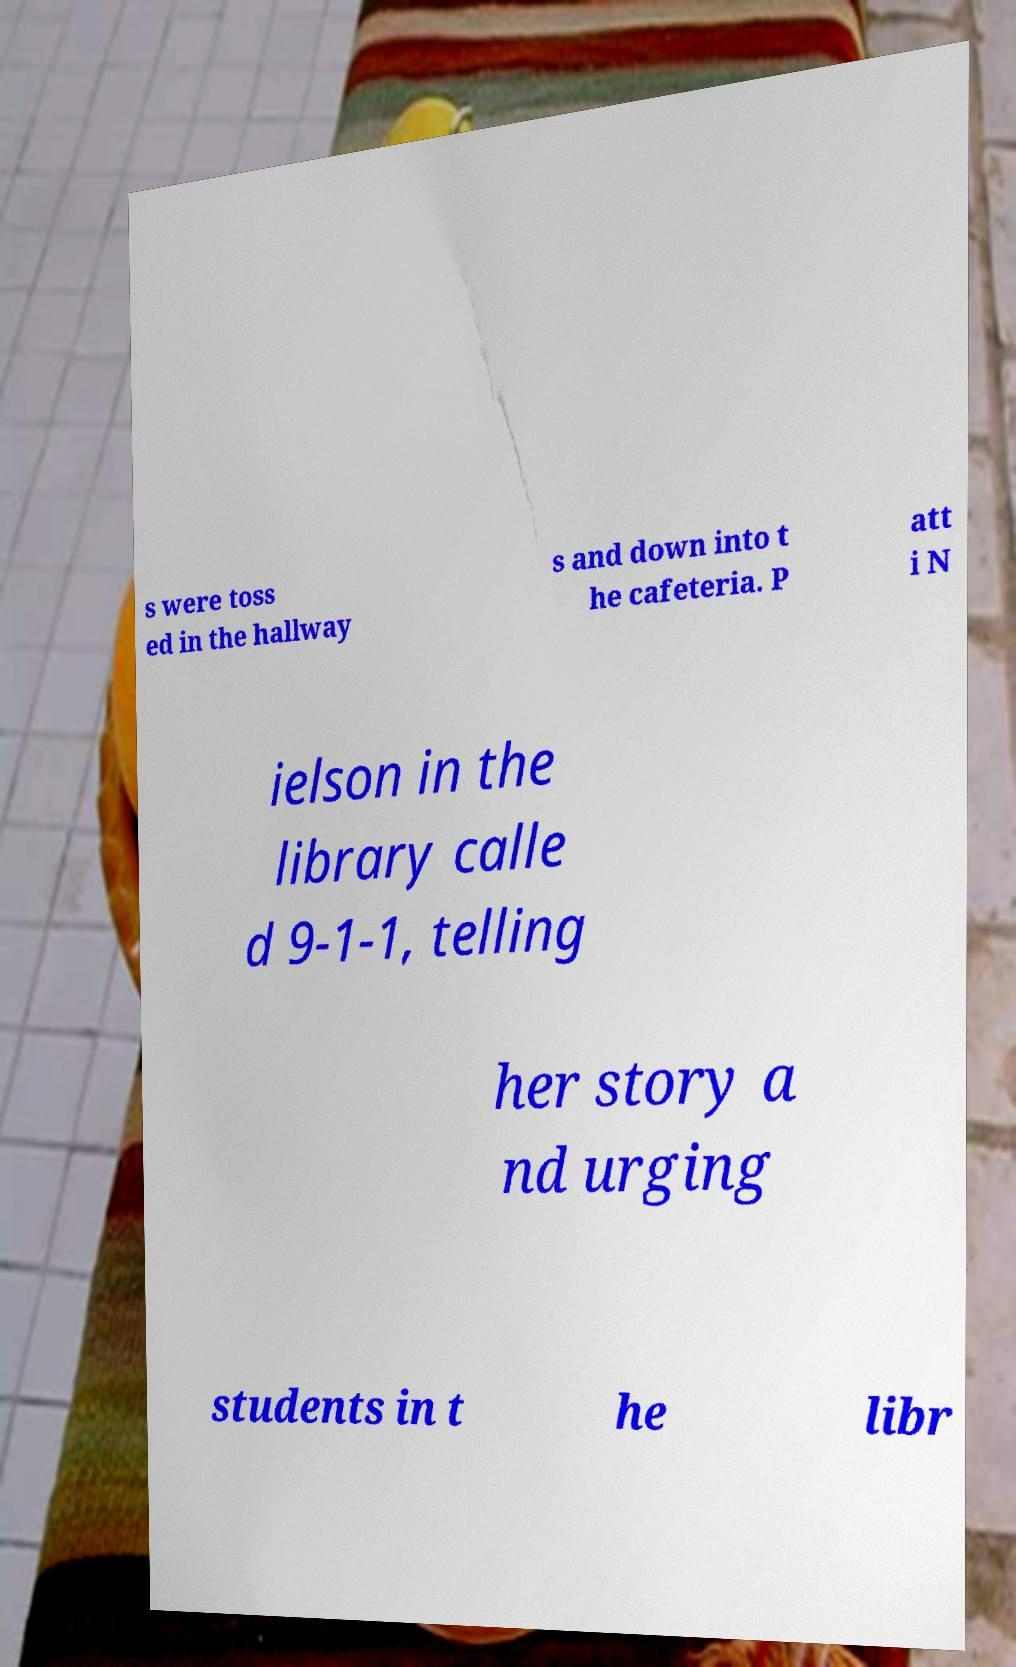There's text embedded in this image that I need extracted. Can you transcribe it verbatim? s were toss ed in the hallway s and down into t he cafeteria. P att i N ielson in the library calle d 9-1-1, telling her story a nd urging students in t he libr 